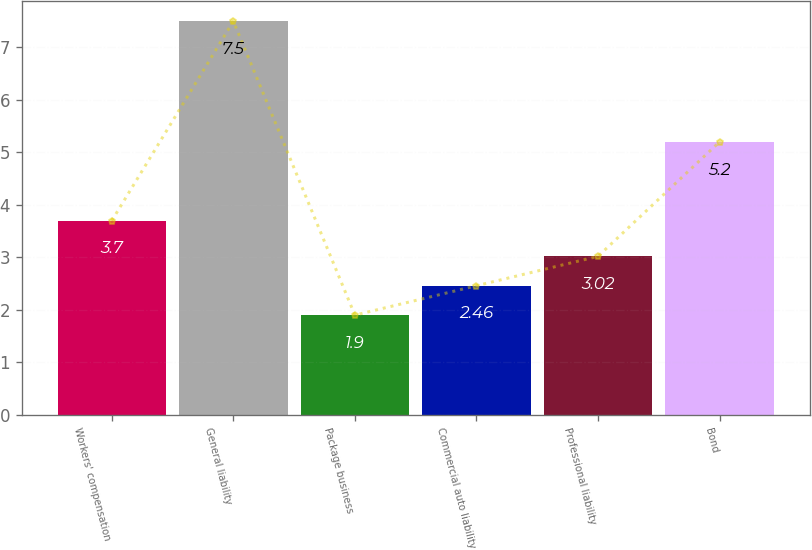<chart> <loc_0><loc_0><loc_500><loc_500><bar_chart><fcel>Workers' compensation<fcel>General liability<fcel>Package business<fcel>Commercial auto liability<fcel>Professional liability<fcel>Bond<nl><fcel>3.7<fcel>7.5<fcel>1.9<fcel>2.46<fcel>3.02<fcel>5.2<nl></chart> 